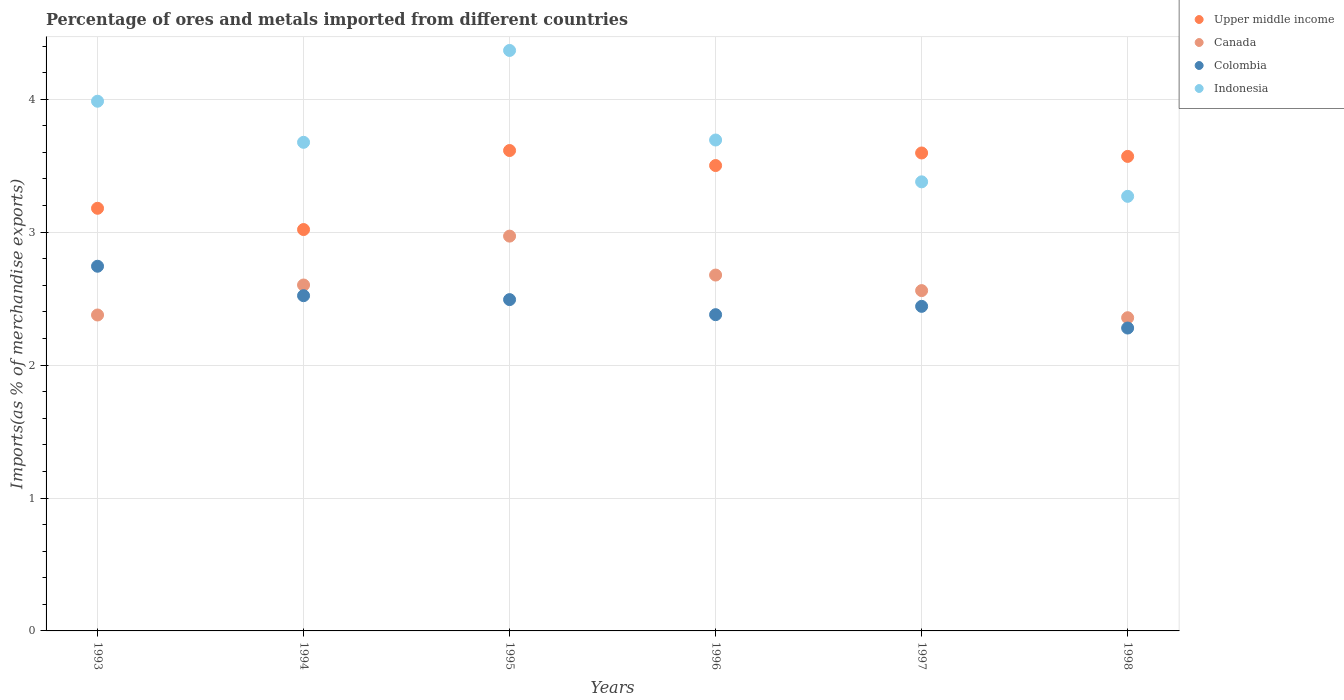How many different coloured dotlines are there?
Your answer should be compact. 4. Is the number of dotlines equal to the number of legend labels?
Your answer should be compact. Yes. What is the percentage of imports to different countries in Indonesia in 1998?
Your answer should be compact. 3.27. Across all years, what is the maximum percentage of imports to different countries in Upper middle income?
Provide a short and direct response. 3.61. Across all years, what is the minimum percentage of imports to different countries in Canada?
Keep it short and to the point. 2.36. In which year was the percentage of imports to different countries in Indonesia maximum?
Provide a succinct answer. 1995. What is the total percentage of imports to different countries in Indonesia in the graph?
Keep it short and to the point. 22.37. What is the difference between the percentage of imports to different countries in Colombia in 1994 and that in 1995?
Keep it short and to the point. 0.03. What is the difference between the percentage of imports to different countries in Indonesia in 1998 and the percentage of imports to different countries in Colombia in 1996?
Keep it short and to the point. 0.89. What is the average percentage of imports to different countries in Upper middle income per year?
Your answer should be compact. 3.41. In the year 1998, what is the difference between the percentage of imports to different countries in Canada and percentage of imports to different countries in Indonesia?
Keep it short and to the point. -0.91. What is the ratio of the percentage of imports to different countries in Indonesia in 1993 to that in 1994?
Give a very brief answer. 1.08. Is the percentage of imports to different countries in Colombia in 1997 less than that in 1998?
Give a very brief answer. No. What is the difference between the highest and the second highest percentage of imports to different countries in Colombia?
Your answer should be very brief. 0.22. What is the difference between the highest and the lowest percentage of imports to different countries in Canada?
Provide a succinct answer. 0.61. In how many years, is the percentage of imports to different countries in Indonesia greater than the average percentage of imports to different countries in Indonesia taken over all years?
Your answer should be compact. 2. Is it the case that in every year, the sum of the percentage of imports to different countries in Colombia and percentage of imports to different countries in Indonesia  is greater than the sum of percentage of imports to different countries in Canada and percentage of imports to different countries in Upper middle income?
Make the answer very short. No. Is it the case that in every year, the sum of the percentage of imports to different countries in Canada and percentage of imports to different countries in Upper middle income  is greater than the percentage of imports to different countries in Colombia?
Offer a very short reply. Yes. How many years are there in the graph?
Your answer should be compact. 6. Are the values on the major ticks of Y-axis written in scientific E-notation?
Your answer should be compact. No. Does the graph contain grids?
Your answer should be compact. Yes. Where does the legend appear in the graph?
Offer a very short reply. Top right. What is the title of the graph?
Provide a succinct answer. Percentage of ores and metals imported from different countries. Does "Argentina" appear as one of the legend labels in the graph?
Make the answer very short. No. What is the label or title of the X-axis?
Offer a very short reply. Years. What is the label or title of the Y-axis?
Ensure brevity in your answer.  Imports(as % of merchandise exports). What is the Imports(as % of merchandise exports) of Upper middle income in 1993?
Keep it short and to the point. 3.18. What is the Imports(as % of merchandise exports) in Canada in 1993?
Provide a short and direct response. 2.38. What is the Imports(as % of merchandise exports) in Colombia in 1993?
Provide a short and direct response. 2.74. What is the Imports(as % of merchandise exports) in Indonesia in 1993?
Your response must be concise. 3.99. What is the Imports(as % of merchandise exports) of Upper middle income in 1994?
Give a very brief answer. 3.02. What is the Imports(as % of merchandise exports) in Canada in 1994?
Your answer should be very brief. 2.6. What is the Imports(as % of merchandise exports) of Colombia in 1994?
Provide a short and direct response. 2.52. What is the Imports(as % of merchandise exports) in Indonesia in 1994?
Make the answer very short. 3.68. What is the Imports(as % of merchandise exports) in Upper middle income in 1995?
Provide a succinct answer. 3.61. What is the Imports(as % of merchandise exports) in Canada in 1995?
Offer a very short reply. 2.97. What is the Imports(as % of merchandise exports) of Colombia in 1995?
Make the answer very short. 2.49. What is the Imports(as % of merchandise exports) in Indonesia in 1995?
Your answer should be very brief. 4.37. What is the Imports(as % of merchandise exports) of Upper middle income in 1996?
Offer a very short reply. 3.5. What is the Imports(as % of merchandise exports) of Canada in 1996?
Provide a short and direct response. 2.68. What is the Imports(as % of merchandise exports) in Colombia in 1996?
Ensure brevity in your answer.  2.38. What is the Imports(as % of merchandise exports) of Indonesia in 1996?
Your response must be concise. 3.69. What is the Imports(as % of merchandise exports) in Upper middle income in 1997?
Your answer should be very brief. 3.6. What is the Imports(as % of merchandise exports) of Canada in 1997?
Your answer should be compact. 2.56. What is the Imports(as % of merchandise exports) of Colombia in 1997?
Your answer should be compact. 2.44. What is the Imports(as % of merchandise exports) of Indonesia in 1997?
Make the answer very short. 3.38. What is the Imports(as % of merchandise exports) in Upper middle income in 1998?
Your answer should be very brief. 3.57. What is the Imports(as % of merchandise exports) of Canada in 1998?
Ensure brevity in your answer.  2.36. What is the Imports(as % of merchandise exports) in Colombia in 1998?
Provide a succinct answer. 2.28. What is the Imports(as % of merchandise exports) of Indonesia in 1998?
Make the answer very short. 3.27. Across all years, what is the maximum Imports(as % of merchandise exports) in Upper middle income?
Keep it short and to the point. 3.61. Across all years, what is the maximum Imports(as % of merchandise exports) in Canada?
Give a very brief answer. 2.97. Across all years, what is the maximum Imports(as % of merchandise exports) in Colombia?
Make the answer very short. 2.74. Across all years, what is the maximum Imports(as % of merchandise exports) of Indonesia?
Your answer should be compact. 4.37. Across all years, what is the minimum Imports(as % of merchandise exports) in Upper middle income?
Your answer should be very brief. 3.02. Across all years, what is the minimum Imports(as % of merchandise exports) of Canada?
Make the answer very short. 2.36. Across all years, what is the minimum Imports(as % of merchandise exports) of Colombia?
Keep it short and to the point. 2.28. Across all years, what is the minimum Imports(as % of merchandise exports) in Indonesia?
Keep it short and to the point. 3.27. What is the total Imports(as % of merchandise exports) in Upper middle income in the graph?
Offer a very short reply. 20.48. What is the total Imports(as % of merchandise exports) of Canada in the graph?
Your answer should be compact. 15.54. What is the total Imports(as % of merchandise exports) in Colombia in the graph?
Ensure brevity in your answer.  14.86. What is the total Imports(as % of merchandise exports) in Indonesia in the graph?
Make the answer very short. 22.37. What is the difference between the Imports(as % of merchandise exports) of Upper middle income in 1993 and that in 1994?
Keep it short and to the point. 0.16. What is the difference between the Imports(as % of merchandise exports) of Canada in 1993 and that in 1994?
Ensure brevity in your answer.  -0.23. What is the difference between the Imports(as % of merchandise exports) in Colombia in 1993 and that in 1994?
Offer a very short reply. 0.22. What is the difference between the Imports(as % of merchandise exports) in Indonesia in 1993 and that in 1994?
Ensure brevity in your answer.  0.31. What is the difference between the Imports(as % of merchandise exports) of Upper middle income in 1993 and that in 1995?
Give a very brief answer. -0.43. What is the difference between the Imports(as % of merchandise exports) in Canada in 1993 and that in 1995?
Give a very brief answer. -0.59. What is the difference between the Imports(as % of merchandise exports) in Colombia in 1993 and that in 1995?
Give a very brief answer. 0.25. What is the difference between the Imports(as % of merchandise exports) in Indonesia in 1993 and that in 1995?
Offer a terse response. -0.38. What is the difference between the Imports(as % of merchandise exports) of Upper middle income in 1993 and that in 1996?
Offer a terse response. -0.32. What is the difference between the Imports(as % of merchandise exports) in Canada in 1993 and that in 1996?
Your response must be concise. -0.3. What is the difference between the Imports(as % of merchandise exports) in Colombia in 1993 and that in 1996?
Offer a very short reply. 0.36. What is the difference between the Imports(as % of merchandise exports) of Indonesia in 1993 and that in 1996?
Provide a short and direct response. 0.29. What is the difference between the Imports(as % of merchandise exports) in Upper middle income in 1993 and that in 1997?
Keep it short and to the point. -0.42. What is the difference between the Imports(as % of merchandise exports) of Canada in 1993 and that in 1997?
Provide a succinct answer. -0.18. What is the difference between the Imports(as % of merchandise exports) of Colombia in 1993 and that in 1997?
Provide a succinct answer. 0.3. What is the difference between the Imports(as % of merchandise exports) in Indonesia in 1993 and that in 1997?
Give a very brief answer. 0.61. What is the difference between the Imports(as % of merchandise exports) in Upper middle income in 1993 and that in 1998?
Keep it short and to the point. -0.39. What is the difference between the Imports(as % of merchandise exports) of Canada in 1993 and that in 1998?
Keep it short and to the point. 0.02. What is the difference between the Imports(as % of merchandise exports) in Colombia in 1993 and that in 1998?
Provide a short and direct response. 0.47. What is the difference between the Imports(as % of merchandise exports) in Indonesia in 1993 and that in 1998?
Provide a succinct answer. 0.72. What is the difference between the Imports(as % of merchandise exports) in Upper middle income in 1994 and that in 1995?
Your response must be concise. -0.59. What is the difference between the Imports(as % of merchandise exports) in Canada in 1994 and that in 1995?
Make the answer very short. -0.37. What is the difference between the Imports(as % of merchandise exports) of Colombia in 1994 and that in 1995?
Your answer should be compact. 0.03. What is the difference between the Imports(as % of merchandise exports) in Indonesia in 1994 and that in 1995?
Give a very brief answer. -0.69. What is the difference between the Imports(as % of merchandise exports) in Upper middle income in 1994 and that in 1996?
Your answer should be compact. -0.48. What is the difference between the Imports(as % of merchandise exports) in Canada in 1994 and that in 1996?
Your answer should be very brief. -0.07. What is the difference between the Imports(as % of merchandise exports) of Colombia in 1994 and that in 1996?
Your answer should be compact. 0.14. What is the difference between the Imports(as % of merchandise exports) of Indonesia in 1994 and that in 1996?
Provide a succinct answer. -0.02. What is the difference between the Imports(as % of merchandise exports) of Upper middle income in 1994 and that in 1997?
Provide a short and direct response. -0.58. What is the difference between the Imports(as % of merchandise exports) of Canada in 1994 and that in 1997?
Offer a very short reply. 0.04. What is the difference between the Imports(as % of merchandise exports) of Colombia in 1994 and that in 1997?
Provide a succinct answer. 0.08. What is the difference between the Imports(as % of merchandise exports) in Indonesia in 1994 and that in 1997?
Your answer should be very brief. 0.3. What is the difference between the Imports(as % of merchandise exports) in Upper middle income in 1994 and that in 1998?
Give a very brief answer. -0.55. What is the difference between the Imports(as % of merchandise exports) in Canada in 1994 and that in 1998?
Provide a succinct answer. 0.25. What is the difference between the Imports(as % of merchandise exports) of Colombia in 1994 and that in 1998?
Your answer should be compact. 0.24. What is the difference between the Imports(as % of merchandise exports) of Indonesia in 1994 and that in 1998?
Keep it short and to the point. 0.41. What is the difference between the Imports(as % of merchandise exports) in Upper middle income in 1995 and that in 1996?
Ensure brevity in your answer.  0.11. What is the difference between the Imports(as % of merchandise exports) of Canada in 1995 and that in 1996?
Keep it short and to the point. 0.29. What is the difference between the Imports(as % of merchandise exports) in Colombia in 1995 and that in 1996?
Give a very brief answer. 0.11. What is the difference between the Imports(as % of merchandise exports) of Indonesia in 1995 and that in 1996?
Your response must be concise. 0.67. What is the difference between the Imports(as % of merchandise exports) in Upper middle income in 1995 and that in 1997?
Keep it short and to the point. 0.02. What is the difference between the Imports(as % of merchandise exports) of Canada in 1995 and that in 1997?
Offer a very short reply. 0.41. What is the difference between the Imports(as % of merchandise exports) of Colombia in 1995 and that in 1997?
Give a very brief answer. 0.05. What is the difference between the Imports(as % of merchandise exports) in Indonesia in 1995 and that in 1997?
Provide a succinct answer. 0.99. What is the difference between the Imports(as % of merchandise exports) in Upper middle income in 1995 and that in 1998?
Provide a succinct answer. 0.04. What is the difference between the Imports(as % of merchandise exports) of Canada in 1995 and that in 1998?
Offer a terse response. 0.61. What is the difference between the Imports(as % of merchandise exports) of Colombia in 1995 and that in 1998?
Your answer should be compact. 0.21. What is the difference between the Imports(as % of merchandise exports) in Indonesia in 1995 and that in 1998?
Ensure brevity in your answer.  1.1. What is the difference between the Imports(as % of merchandise exports) in Upper middle income in 1996 and that in 1997?
Offer a very short reply. -0.09. What is the difference between the Imports(as % of merchandise exports) of Canada in 1996 and that in 1997?
Your answer should be very brief. 0.12. What is the difference between the Imports(as % of merchandise exports) in Colombia in 1996 and that in 1997?
Ensure brevity in your answer.  -0.06. What is the difference between the Imports(as % of merchandise exports) in Indonesia in 1996 and that in 1997?
Your answer should be compact. 0.31. What is the difference between the Imports(as % of merchandise exports) of Upper middle income in 1996 and that in 1998?
Your response must be concise. -0.07. What is the difference between the Imports(as % of merchandise exports) in Canada in 1996 and that in 1998?
Your response must be concise. 0.32. What is the difference between the Imports(as % of merchandise exports) in Colombia in 1996 and that in 1998?
Your answer should be compact. 0.1. What is the difference between the Imports(as % of merchandise exports) of Indonesia in 1996 and that in 1998?
Give a very brief answer. 0.42. What is the difference between the Imports(as % of merchandise exports) in Upper middle income in 1997 and that in 1998?
Keep it short and to the point. 0.03. What is the difference between the Imports(as % of merchandise exports) in Canada in 1997 and that in 1998?
Ensure brevity in your answer.  0.2. What is the difference between the Imports(as % of merchandise exports) in Colombia in 1997 and that in 1998?
Give a very brief answer. 0.16. What is the difference between the Imports(as % of merchandise exports) in Indonesia in 1997 and that in 1998?
Your answer should be compact. 0.11. What is the difference between the Imports(as % of merchandise exports) in Upper middle income in 1993 and the Imports(as % of merchandise exports) in Canada in 1994?
Offer a terse response. 0.58. What is the difference between the Imports(as % of merchandise exports) of Upper middle income in 1993 and the Imports(as % of merchandise exports) of Colombia in 1994?
Offer a terse response. 0.66. What is the difference between the Imports(as % of merchandise exports) in Upper middle income in 1993 and the Imports(as % of merchandise exports) in Indonesia in 1994?
Ensure brevity in your answer.  -0.5. What is the difference between the Imports(as % of merchandise exports) in Canada in 1993 and the Imports(as % of merchandise exports) in Colombia in 1994?
Your response must be concise. -0.15. What is the difference between the Imports(as % of merchandise exports) of Canada in 1993 and the Imports(as % of merchandise exports) of Indonesia in 1994?
Provide a short and direct response. -1.3. What is the difference between the Imports(as % of merchandise exports) of Colombia in 1993 and the Imports(as % of merchandise exports) of Indonesia in 1994?
Keep it short and to the point. -0.93. What is the difference between the Imports(as % of merchandise exports) of Upper middle income in 1993 and the Imports(as % of merchandise exports) of Canada in 1995?
Your response must be concise. 0.21. What is the difference between the Imports(as % of merchandise exports) of Upper middle income in 1993 and the Imports(as % of merchandise exports) of Colombia in 1995?
Offer a very short reply. 0.69. What is the difference between the Imports(as % of merchandise exports) in Upper middle income in 1993 and the Imports(as % of merchandise exports) in Indonesia in 1995?
Make the answer very short. -1.19. What is the difference between the Imports(as % of merchandise exports) in Canada in 1993 and the Imports(as % of merchandise exports) in Colombia in 1995?
Your response must be concise. -0.12. What is the difference between the Imports(as % of merchandise exports) of Canada in 1993 and the Imports(as % of merchandise exports) of Indonesia in 1995?
Your answer should be compact. -1.99. What is the difference between the Imports(as % of merchandise exports) in Colombia in 1993 and the Imports(as % of merchandise exports) in Indonesia in 1995?
Make the answer very short. -1.62. What is the difference between the Imports(as % of merchandise exports) in Upper middle income in 1993 and the Imports(as % of merchandise exports) in Canada in 1996?
Your answer should be compact. 0.5. What is the difference between the Imports(as % of merchandise exports) of Upper middle income in 1993 and the Imports(as % of merchandise exports) of Colombia in 1996?
Make the answer very short. 0.8. What is the difference between the Imports(as % of merchandise exports) in Upper middle income in 1993 and the Imports(as % of merchandise exports) in Indonesia in 1996?
Your response must be concise. -0.51. What is the difference between the Imports(as % of merchandise exports) of Canada in 1993 and the Imports(as % of merchandise exports) of Colombia in 1996?
Your answer should be very brief. -0. What is the difference between the Imports(as % of merchandise exports) in Canada in 1993 and the Imports(as % of merchandise exports) in Indonesia in 1996?
Your response must be concise. -1.32. What is the difference between the Imports(as % of merchandise exports) of Colombia in 1993 and the Imports(as % of merchandise exports) of Indonesia in 1996?
Offer a terse response. -0.95. What is the difference between the Imports(as % of merchandise exports) of Upper middle income in 1993 and the Imports(as % of merchandise exports) of Canada in 1997?
Offer a very short reply. 0.62. What is the difference between the Imports(as % of merchandise exports) in Upper middle income in 1993 and the Imports(as % of merchandise exports) in Colombia in 1997?
Offer a terse response. 0.74. What is the difference between the Imports(as % of merchandise exports) of Upper middle income in 1993 and the Imports(as % of merchandise exports) of Indonesia in 1997?
Provide a short and direct response. -0.2. What is the difference between the Imports(as % of merchandise exports) of Canada in 1993 and the Imports(as % of merchandise exports) of Colombia in 1997?
Give a very brief answer. -0.07. What is the difference between the Imports(as % of merchandise exports) in Canada in 1993 and the Imports(as % of merchandise exports) in Indonesia in 1997?
Provide a short and direct response. -1. What is the difference between the Imports(as % of merchandise exports) of Colombia in 1993 and the Imports(as % of merchandise exports) of Indonesia in 1997?
Ensure brevity in your answer.  -0.64. What is the difference between the Imports(as % of merchandise exports) in Upper middle income in 1993 and the Imports(as % of merchandise exports) in Canada in 1998?
Make the answer very short. 0.82. What is the difference between the Imports(as % of merchandise exports) in Upper middle income in 1993 and the Imports(as % of merchandise exports) in Colombia in 1998?
Offer a terse response. 0.9. What is the difference between the Imports(as % of merchandise exports) in Upper middle income in 1993 and the Imports(as % of merchandise exports) in Indonesia in 1998?
Your response must be concise. -0.09. What is the difference between the Imports(as % of merchandise exports) of Canada in 1993 and the Imports(as % of merchandise exports) of Colombia in 1998?
Provide a succinct answer. 0.1. What is the difference between the Imports(as % of merchandise exports) of Canada in 1993 and the Imports(as % of merchandise exports) of Indonesia in 1998?
Ensure brevity in your answer.  -0.89. What is the difference between the Imports(as % of merchandise exports) in Colombia in 1993 and the Imports(as % of merchandise exports) in Indonesia in 1998?
Offer a very short reply. -0.53. What is the difference between the Imports(as % of merchandise exports) in Upper middle income in 1994 and the Imports(as % of merchandise exports) in Canada in 1995?
Give a very brief answer. 0.05. What is the difference between the Imports(as % of merchandise exports) of Upper middle income in 1994 and the Imports(as % of merchandise exports) of Colombia in 1995?
Your answer should be compact. 0.53. What is the difference between the Imports(as % of merchandise exports) in Upper middle income in 1994 and the Imports(as % of merchandise exports) in Indonesia in 1995?
Provide a short and direct response. -1.35. What is the difference between the Imports(as % of merchandise exports) in Canada in 1994 and the Imports(as % of merchandise exports) in Colombia in 1995?
Your response must be concise. 0.11. What is the difference between the Imports(as % of merchandise exports) of Canada in 1994 and the Imports(as % of merchandise exports) of Indonesia in 1995?
Offer a very short reply. -1.76. What is the difference between the Imports(as % of merchandise exports) in Colombia in 1994 and the Imports(as % of merchandise exports) in Indonesia in 1995?
Your response must be concise. -1.84. What is the difference between the Imports(as % of merchandise exports) in Upper middle income in 1994 and the Imports(as % of merchandise exports) in Canada in 1996?
Your response must be concise. 0.34. What is the difference between the Imports(as % of merchandise exports) of Upper middle income in 1994 and the Imports(as % of merchandise exports) of Colombia in 1996?
Offer a terse response. 0.64. What is the difference between the Imports(as % of merchandise exports) of Upper middle income in 1994 and the Imports(as % of merchandise exports) of Indonesia in 1996?
Your answer should be compact. -0.67. What is the difference between the Imports(as % of merchandise exports) in Canada in 1994 and the Imports(as % of merchandise exports) in Colombia in 1996?
Provide a succinct answer. 0.22. What is the difference between the Imports(as % of merchandise exports) of Canada in 1994 and the Imports(as % of merchandise exports) of Indonesia in 1996?
Offer a terse response. -1.09. What is the difference between the Imports(as % of merchandise exports) in Colombia in 1994 and the Imports(as % of merchandise exports) in Indonesia in 1996?
Keep it short and to the point. -1.17. What is the difference between the Imports(as % of merchandise exports) in Upper middle income in 1994 and the Imports(as % of merchandise exports) in Canada in 1997?
Keep it short and to the point. 0.46. What is the difference between the Imports(as % of merchandise exports) in Upper middle income in 1994 and the Imports(as % of merchandise exports) in Colombia in 1997?
Ensure brevity in your answer.  0.58. What is the difference between the Imports(as % of merchandise exports) of Upper middle income in 1994 and the Imports(as % of merchandise exports) of Indonesia in 1997?
Ensure brevity in your answer.  -0.36. What is the difference between the Imports(as % of merchandise exports) of Canada in 1994 and the Imports(as % of merchandise exports) of Colombia in 1997?
Keep it short and to the point. 0.16. What is the difference between the Imports(as % of merchandise exports) in Canada in 1994 and the Imports(as % of merchandise exports) in Indonesia in 1997?
Make the answer very short. -0.78. What is the difference between the Imports(as % of merchandise exports) of Colombia in 1994 and the Imports(as % of merchandise exports) of Indonesia in 1997?
Ensure brevity in your answer.  -0.86. What is the difference between the Imports(as % of merchandise exports) in Upper middle income in 1994 and the Imports(as % of merchandise exports) in Canada in 1998?
Provide a succinct answer. 0.66. What is the difference between the Imports(as % of merchandise exports) of Upper middle income in 1994 and the Imports(as % of merchandise exports) of Colombia in 1998?
Give a very brief answer. 0.74. What is the difference between the Imports(as % of merchandise exports) in Upper middle income in 1994 and the Imports(as % of merchandise exports) in Indonesia in 1998?
Your answer should be compact. -0.25. What is the difference between the Imports(as % of merchandise exports) of Canada in 1994 and the Imports(as % of merchandise exports) of Colombia in 1998?
Ensure brevity in your answer.  0.32. What is the difference between the Imports(as % of merchandise exports) of Canada in 1994 and the Imports(as % of merchandise exports) of Indonesia in 1998?
Give a very brief answer. -0.67. What is the difference between the Imports(as % of merchandise exports) of Colombia in 1994 and the Imports(as % of merchandise exports) of Indonesia in 1998?
Provide a short and direct response. -0.75. What is the difference between the Imports(as % of merchandise exports) of Upper middle income in 1995 and the Imports(as % of merchandise exports) of Canada in 1996?
Keep it short and to the point. 0.94. What is the difference between the Imports(as % of merchandise exports) in Upper middle income in 1995 and the Imports(as % of merchandise exports) in Colombia in 1996?
Your response must be concise. 1.24. What is the difference between the Imports(as % of merchandise exports) of Upper middle income in 1995 and the Imports(as % of merchandise exports) of Indonesia in 1996?
Make the answer very short. -0.08. What is the difference between the Imports(as % of merchandise exports) of Canada in 1995 and the Imports(as % of merchandise exports) of Colombia in 1996?
Give a very brief answer. 0.59. What is the difference between the Imports(as % of merchandise exports) in Canada in 1995 and the Imports(as % of merchandise exports) in Indonesia in 1996?
Your response must be concise. -0.72. What is the difference between the Imports(as % of merchandise exports) of Colombia in 1995 and the Imports(as % of merchandise exports) of Indonesia in 1996?
Provide a short and direct response. -1.2. What is the difference between the Imports(as % of merchandise exports) of Upper middle income in 1995 and the Imports(as % of merchandise exports) of Canada in 1997?
Keep it short and to the point. 1.05. What is the difference between the Imports(as % of merchandise exports) in Upper middle income in 1995 and the Imports(as % of merchandise exports) in Colombia in 1997?
Provide a succinct answer. 1.17. What is the difference between the Imports(as % of merchandise exports) of Upper middle income in 1995 and the Imports(as % of merchandise exports) of Indonesia in 1997?
Give a very brief answer. 0.24. What is the difference between the Imports(as % of merchandise exports) of Canada in 1995 and the Imports(as % of merchandise exports) of Colombia in 1997?
Give a very brief answer. 0.53. What is the difference between the Imports(as % of merchandise exports) of Canada in 1995 and the Imports(as % of merchandise exports) of Indonesia in 1997?
Ensure brevity in your answer.  -0.41. What is the difference between the Imports(as % of merchandise exports) of Colombia in 1995 and the Imports(as % of merchandise exports) of Indonesia in 1997?
Make the answer very short. -0.89. What is the difference between the Imports(as % of merchandise exports) in Upper middle income in 1995 and the Imports(as % of merchandise exports) in Canada in 1998?
Ensure brevity in your answer.  1.26. What is the difference between the Imports(as % of merchandise exports) of Upper middle income in 1995 and the Imports(as % of merchandise exports) of Colombia in 1998?
Provide a short and direct response. 1.34. What is the difference between the Imports(as % of merchandise exports) of Upper middle income in 1995 and the Imports(as % of merchandise exports) of Indonesia in 1998?
Keep it short and to the point. 0.34. What is the difference between the Imports(as % of merchandise exports) in Canada in 1995 and the Imports(as % of merchandise exports) in Colombia in 1998?
Offer a very short reply. 0.69. What is the difference between the Imports(as % of merchandise exports) in Canada in 1995 and the Imports(as % of merchandise exports) in Indonesia in 1998?
Provide a succinct answer. -0.3. What is the difference between the Imports(as % of merchandise exports) in Colombia in 1995 and the Imports(as % of merchandise exports) in Indonesia in 1998?
Make the answer very short. -0.78. What is the difference between the Imports(as % of merchandise exports) of Upper middle income in 1996 and the Imports(as % of merchandise exports) of Canada in 1997?
Your answer should be very brief. 0.94. What is the difference between the Imports(as % of merchandise exports) in Upper middle income in 1996 and the Imports(as % of merchandise exports) in Colombia in 1997?
Provide a succinct answer. 1.06. What is the difference between the Imports(as % of merchandise exports) of Upper middle income in 1996 and the Imports(as % of merchandise exports) of Indonesia in 1997?
Offer a very short reply. 0.12. What is the difference between the Imports(as % of merchandise exports) in Canada in 1996 and the Imports(as % of merchandise exports) in Colombia in 1997?
Provide a succinct answer. 0.24. What is the difference between the Imports(as % of merchandise exports) in Canada in 1996 and the Imports(as % of merchandise exports) in Indonesia in 1997?
Your answer should be compact. -0.7. What is the difference between the Imports(as % of merchandise exports) in Colombia in 1996 and the Imports(as % of merchandise exports) in Indonesia in 1997?
Give a very brief answer. -1. What is the difference between the Imports(as % of merchandise exports) in Upper middle income in 1996 and the Imports(as % of merchandise exports) in Canada in 1998?
Provide a succinct answer. 1.15. What is the difference between the Imports(as % of merchandise exports) of Upper middle income in 1996 and the Imports(as % of merchandise exports) of Colombia in 1998?
Give a very brief answer. 1.22. What is the difference between the Imports(as % of merchandise exports) in Upper middle income in 1996 and the Imports(as % of merchandise exports) in Indonesia in 1998?
Provide a short and direct response. 0.23. What is the difference between the Imports(as % of merchandise exports) of Canada in 1996 and the Imports(as % of merchandise exports) of Colombia in 1998?
Your answer should be compact. 0.4. What is the difference between the Imports(as % of merchandise exports) of Canada in 1996 and the Imports(as % of merchandise exports) of Indonesia in 1998?
Give a very brief answer. -0.59. What is the difference between the Imports(as % of merchandise exports) in Colombia in 1996 and the Imports(as % of merchandise exports) in Indonesia in 1998?
Your response must be concise. -0.89. What is the difference between the Imports(as % of merchandise exports) in Upper middle income in 1997 and the Imports(as % of merchandise exports) in Canada in 1998?
Provide a short and direct response. 1.24. What is the difference between the Imports(as % of merchandise exports) of Upper middle income in 1997 and the Imports(as % of merchandise exports) of Colombia in 1998?
Your response must be concise. 1.32. What is the difference between the Imports(as % of merchandise exports) in Upper middle income in 1997 and the Imports(as % of merchandise exports) in Indonesia in 1998?
Make the answer very short. 0.33. What is the difference between the Imports(as % of merchandise exports) in Canada in 1997 and the Imports(as % of merchandise exports) in Colombia in 1998?
Provide a short and direct response. 0.28. What is the difference between the Imports(as % of merchandise exports) of Canada in 1997 and the Imports(as % of merchandise exports) of Indonesia in 1998?
Your answer should be compact. -0.71. What is the difference between the Imports(as % of merchandise exports) in Colombia in 1997 and the Imports(as % of merchandise exports) in Indonesia in 1998?
Provide a succinct answer. -0.83. What is the average Imports(as % of merchandise exports) in Upper middle income per year?
Give a very brief answer. 3.41. What is the average Imports(as % of merchandise exports) in Canada per year?
Your answer should be compact. 2.59. What is the average Imports(as % of merchandise exports) in Colombia per year?
Offer a terse response. 2.48. What is the average Imports(as % of merchandise exports) in Indonesia per year?
Ensure brevity in your answer.  3.73. In the year 1993, what is the difference between the Imports(as % of merchandise exports) of Upper middle income and Imports(as % of merchandise exports) of Canada?
Your answer should be very brief. 0.8. In the year 1993, what is the difference between the Imports(as % of merchandise exports) in Upper middle income and Imports(as % of merchandise exports) in Colombia?
Your answer should be very brief. 0.44. In the year 1993, what is the difference between the Imports(as % of merchandise exports) in Upper middle income and Imports(as % of merchandise exports) in Indonesia?
Make the answer very short. -0.81. In the year 1993, what is the difference between the Imports(as % of merchandise exports) of Canada and Imports(as % of merchandise exports) of Colombia?
Offer a terse response. -0.37. In the year 1993, what is the difference between the Imports(as % of merchandise exports) of Canada and Imports(as % of merchandise exports) of Indonesia?
Your response must be concise. -1.61. In the year 1993, what is the difference between the Imports(as % of merchandise exports) of Colombia and Imports(as % of merchandise exports) of Indonesia?
Offer a terse response. -1.24. In the year 1994, what is the difference between the Imports(as % of merchandise exports) in Upper middle income and Imports(as % of merchandise exports) in Canada?
Your answer should be compact. 0.42. In the year 1994, what is the difference between the Imports(as % of merchandise exports) of Upper middle income and Imports(as % of merchandise exports) of Colombia?
Make the answer very short. 0.5. In the year 1994, what is the difference between the Imports(as % of merchandise exports) of Upper middle income and Imports(as % of merchandise exports) of Indonesia?
Ensure brevity in your answer.  -0.66. In the year 1994, what is the difference between the Imports(as % of merchandise exports) of Canada and Imports(as % of merchandise exports) of Colombia?
Make the answer very short. 0.08. In the year 1994, what is the difference between the Imports(as % of merchandise exports) in Canada and Imports(as % of merchandise exports) in Indonesia?
Ensure brevity in your answer.  -1.07. In the year 1994, what is the difference between the Imports(as % of merchandise exports) in Colombia and Imports(as % of merchandise exports) in Indonesia?
Offer a terse response. -1.15. In the year 1995, what is the difference between the Imports(as % of merchandise exports) in Upper middle income and Imports(as % of merchandise exports) in Canada?
Provide a short and direct response. 0.64. In the year 1995, what is the difference between the Imports(as % of merchandise exports) of Upper middle income and Imports(as % of merchandise exports) of Colombia?
Keep it short and to the point. 1.12. In the year 1995, what is the difference between the Imports(as % of merchandise exports) in Upper middle income and Imports(as % of merchandise exports) in Indonesia?
Make the answer very short. -0.75. In the year 1995, what is the difference between the Imports(as % of merchandise exports) in Canada and Imports(as % of merchandise exports) in Colombia?
Your response must be concise. 0.48. In the year 1995, what is the difference between the Imports(as % of merchandise exports) of Canada and Imports(as % of merchandise exports) of Indonesia?
Provide a succinct answer. -1.4. In the year 1995, what is the difference between the Imports(as % of merchandise exports) in Colombia and Imports(as % of merchandise exports) in Indonesia?
Ensure brevity in your answer.  -1.87. In the year 1996, what is the difference between the Imports(as % of merchandise exports) in Upper middle income and Imports(as % of merchandise exports) in Canada?
Ensure brevity in your answer.  0.82. In the year 1996, what is the difference between the Imports(as % of merchandise exports) of Upper middle income and Imports(as % of merchandise exports) of Colombia?
Offer a terse response. 1.12. In the year 1996, what is the difference between the Imports(as % of merchandise exports) in Upper middle income and Imports(as % of merchandise exports) in Indonesia?
Provide a succinct answer. -0.19. In the year 1996, what is the difference between the Imports(as % of merchandise exports) in Canada and Imports(as % of merchandise exports) in Colombia?
Provide a short and direct response. 0.3. In the year 1996, what is the difference between the Imports(as % of merchandise exports) in Canada and Imports(as % of merchandise exports) in Indonesia?
Your answer should be compact. -1.02. In the year 1996, what is the difference between the Imports(as % of merchandise exports) of Colombia and Imports(as % of merchandise exports) of Indonesia?
Provide a short and direct response. -1.31. In the year 1997, what is the difference between the Imports(as % of merchandise exports) in Upper middle income and Imports(as % of merchandise exports) in Canada?
Offer a very short reply. 1.04. In the year 1997, what is the difference between the Imports(as % of merchandise exports) of Upper middle income and Imports(as % of merchandise exports) of Colombia?
Provide a short and direct response. 1.15. In the year 1997, what is the difference between the Imports(as % of merchandise exports) of Upper middle income and Imports(as % of merchandise exports) of Indonesia?
Make the answer very short. 0.22. In the year 1997, what is the difference between the Imports(as % of merchandise exports) of Canada and Imports(as % of merchandise exports) of Colombia?
Ensure brevity in your answer.  0.12. In the year 1997, what is the difference between the Imports(as % of merchandise exports) in Canada and Imports(as % of merchandise exports) in Indonesia?
Provide a succinct answer. -0.82. In the year 1997, what is the difference between the Imports(as % of merchandise exports) of Colombia and Imports(as % of merchandise exports) of Indonesia?
Your answer should be very brief. -0.94. In the year 1998, what is the difference between the Imports(as % of merchandise exports) in Upper middle income and Imports(as % of merchandise exports) in Canada?
Offer a very short reply. 1.21. In the year 1998, what is the difference between the Imports(as % of merchandise exports) of Upper middle income and Imports(as % of merchandise exports) of Colombia?
Keep it short and to the point. 1.29. In the year 1998, what is the difference between the Imports(as % of merchandise exports) in Upper middle income and Imports(as % of merchandise exports) in Indonesia?
Provide a succinct answer. 0.3. In the year 1998, what is the difference between the Imports(as % of merchandise exports) of Canada and Imports(as % of merchandise exports) of Colombia?
Your answer should be compact. 0.08. In the year 1998, what is the difference between the Imports(as % of merchandise exports) of Canada and Imports(as % of merchandise exports) of Indonesia?
Offer a very short reply. -0.91. In the year 1998, what is the difference between the Imports(as % of merchandise exports) of Colombia and Imports(as % of merchandise exports) of Indonesia?
Your answer should be compact. -0.99. What is the ratio of the Imports(as % of merchandise exports) in Upper middle income in 1993 to that in 1994?
Provide a succinct answer. 1.05. What is the ratio of the Imports(as % of merchandise exports) in Canada in 1993 to that in 1994?
Ensure brevity in your answer.  0.91. What is the ratio of the Imports(as % of merchandise exports) of Colombia in 1993 to that in 1994?
Give a very brief answer. 1.09. What is the ratio of the Imports(as % of merchandise exports) of Indonesia in 1993 to that in 1994?
Provide a short and direct response. 1.08. What is the ratio of the Imports(as % of merchandise exports) in Upper middle income in 1993 to that in 1995?
Keep it short and to the point. 0.88. What is the ratio of the Imports(as % of merchandise exports) in Canada in 1993 to that in 1995?
Make the answer very short. 0.8. What is the ratio of the Imports(as % of merchandise exports) of Colombia in 1993 to that in 1995?
Offer a very short reply. 1.1. What is the ratio of the Imports(as % of merchandise exports) of Indonesia in 1993 to that in 1995?
Your answer should be very brief. 0.91. What is the ratio of the Imports(as % of merchandise exports) of Upper middle income in 1993 to that in 1996?
Give a very brief answer. 0.91. What is the ratio of the Imports(as % of merchandise exports) in Canada in 1993 to that in 1996?
Your answer should be compact. 0.89. What is the ratio of the Imports(as % of merchandise exports) of Colombia in 1993 to that in 1996?
Provide a succinct answer. 1.15. What is the ratio of the Imports(as % of merchandise exports) in Indonesia in 1993 to that in 1996?
Keep it short and to the point. 1.08. What is the ratio of the Imports(as % of merchandise exports) in Upper middle income in 1993 to that in 1997?
Offer a terse response. 0.88. What is the ratio of the Imports(as % of merchandise exports) of Canada in 1993 to that in 1997?
Offer a terse response. 0.93. What is the ratio of the Imports(as % of merchandise exports) in Colombia in 1993 to that in 1997?
Make the answer very short. 1.12. What is the ratio of the Imports(as % of merchandise exports) in Indonesia in 1993 to that in 1997?
Provide a succinct answer. 1.18. What is the ratio of the Imports(as % of merchandise exports) of Upper middle income in 1993 to that in 1998?
Ensure brevity in your answer.  0.89. What is the ratio of the Imports(as % of merchandise exports) in Canada in 1993 to that in 1998?
Provide a succinct answer. 1.01. What is the ratio of the Imports(as % of merchandise exports) in Colombia in 1993 to that in 1998?
Offer a very short reply. 1.2. What is the ratio of the Imports(as % of merchandise exports) of Indonesia in 1993 to that in 1998?
Offer a very short reply. 1.22. What is the ratio of the Imports(as % of merchandise exports) in Upper middle income in 1994 to that in 1995?
Keep it short and to the point. 0.84. What is the ratio of the Imports(as % of merchandise exports) of Canada in 1994 to that in 1995?
Offer a very short reply. 0.88. What is the ratio of the Imports(as % of merchandise exports) in Colombia in 1994 to that in 1995?
Your answer should be compact. 1.01. What is the ratio of the Imports(as % of merchandise exports) of Indonesia in 1994 to that in 1995?
Provide a succinct answer. 0.84. What is the ratio of the Imports(as % of merchandise exports) of Upper middle income in 1994 to that in 1996?
Offer a very short reply. 0.86. What is the ratio of the Imports(as % of merchandise exports) in Canada in 1994 to that in 1996?
Ensure brevity in your answer.  0.97. What is the ratio of the Imports(as % of merchandise exports) in Colombia in 1994 to that in 1996?
Offer a terse response. 1.06. What is the ratio of the Imports(as % of merchandise exports) in Indonesia in 1994 to that in 1996?
Your response must be concise. 1. What is the ratio of the Imports(as % of merchandise exports) of Upper middle income in 1994 to that in 1997?
Keep it short and to the point. 0.84. What is the ratio of the Imports(as % of merchandise exports) of Canada in 1994 to that in 1997?
Make the answer very short. 1.02. What is the ratio of the Imports(as % of merchandise exports) in Colombia in 1994 to that in 1997?
Your answer should be compact. 1.03. What is the ratio of the Imports(as % of merchandise exports) in Indonesia in 1994 to that in 1997?
Ensure brevity in your answer.  1.09. What is the ratio of the Imports(as % of merchandise exports) in Upper middle income in 1994 to that in 1998?
Your answer should be very brief. 0.85. What is the ratio of the Imports(as % of merchandise exports) of Canada in 1994 to that in 1998?
Your answer should be compact. 1.1. What is the ratio of the Imports(as % of merchandise exports) in Colombia in 1994 to that in 1998?
Keep it short and to the point. 1.11. What is the ratio of the Imports(as % of merchandise exports) of Indonesia in 1994 to that in 1998?
Your answer should be very brief. 1.12. What is the ratio of the Imports(as % of merchandise exports) in Upper middle income in 1995 to that in 1996?
Make the answer very short. 1.03. What is the ratio of the Imports(as % of merchandise exports) in Canada in 1995 to that in 1996?
Your response must be concise. 1.11. What is the ratio of the Imports(as % of merchandise exports) of Colombia in 1995 to that in 1996?
Provide a short and direct response. 1.05. What is the ratio of the Imports(as % of merchandise exports) of Indonesia in 1995 to that in 1996?
Offer a terse response. 1.18. What is the ratio of the Imports(as % of merchandise exports) in Canada in 1995 to that in 1997?
Your answer should be very brief. 1.16. What is the ratio of the Imports(as % of merchandise exports) of Colombia in 1995 to that in 1997?
Provide a short and direct response. 1.02. What is the ratio of the Imports(as % of merchandise exports) of Indonesia in 1995 to that in 1997?
Provide a succinct answer. 1.29. What is the ratio of the Imports(as % of merchandise exports) of Upper middle income in 1995 to that in 1998?
Keep it short and to the point. 1.01. What is the ratio of the Imports(as % of merchandise exports) in Canada in 1995 to that in 1998?
Ensure brevity in your answer.  1.26. What is the ratio of the Imports(as % of merchandise exports) in Colombia in 1995 to that in 1998?
Keep it short and to the point. 1.09. What is the ratio of the Imports(as % of merchandise exports) of Indonesia in 1995 to that in 1998?
Provide a short and direct response. 1.34. What is the ratio of the Imports(as % of merchandise exports) of Upper middle income in 1996 to that in 1997?
Ensure brevity in your answer.  0.97. What is the ratio of the Imports(as % of merchandise exports) in Canada in 1996 to that in 1997?
Provide a short and direct response. 1.05. What is the ratio of the Imports(as % of merchandise exports) in Colombia in 1996 to that in 1997?
Your response must be concise. 0.97. What is the ratio of the Imports(as % of merchandise exports) in Indonesia in 1996 to that in 1997?
Your response must be concise. 1.09. What is the ratio of the Imports(as % of merchandise exports) in Upper middle income in 1996 to that in 1998?
Offer a very short reply. 0.98. What is the ratio of the Imports(as % of merchandise exports) in Canada in 1996 to that in 1998?
Give a very brief answer. 1.14. What is the ratio of the Imports(as % of merchandise exports) in Colombia in 1996 to that in 1998?
Keep it short and to the point. 1.04. What is the ratio of the Imports(as % of merchandise exports) in Indonesia in 1996 to that in 1998?
Your answer should be compact. 1.13. What is the ratio of the Imports(as % of merchandise exports) in Canada in 1997 to that in 1998?
Your answer should be very brief. 1.09. What is the ratio of the Imports(as % of merchandise exports) in Colombia in 1997 to that in 1998?
Your response must be concise. 1.07. What is the ratio of the Imports(as % of merchandise exports) of Indonesia in 1997 to that in 1998?
Your answer should be compact. 1.03. What is the difference between the highest and the second highest Imports(as % of merchandise exports) of Upper middle income?
Give a very brief answer. 0.02. What is the difference between the highest and the second highest Imports(as % of merchandise exports) of Canada?
Your answer should be compact. 0.29. What is the difference between the highest and the second highest Imports(as % of merchandise exports) of Colombia?
Make the answer very short. 0.22. What is the difference between the highest and the second highest Imports(as % of merchandise exports) of Indonesia?
Provide a short and direct response. 0.38. What is the difference between the highest and the lowest Imports(as % of merchandise exports) of Upper middle income?
Keep it short and to the point. 0.59. What is the difference between the highest and the lowest Imports(as % of merchandise exports) of Canada?
Your response must be concise. 0.61. What is the difference between the highest and the lowest Imports(as % of merchandise exports) in Colombia?
Ensure brevity in your answer.  0.47. What is the difference between the highest and the lowest Imports(as % of merchandise exports) in Indonesia?
Your answer should be very brief. 1.1. 